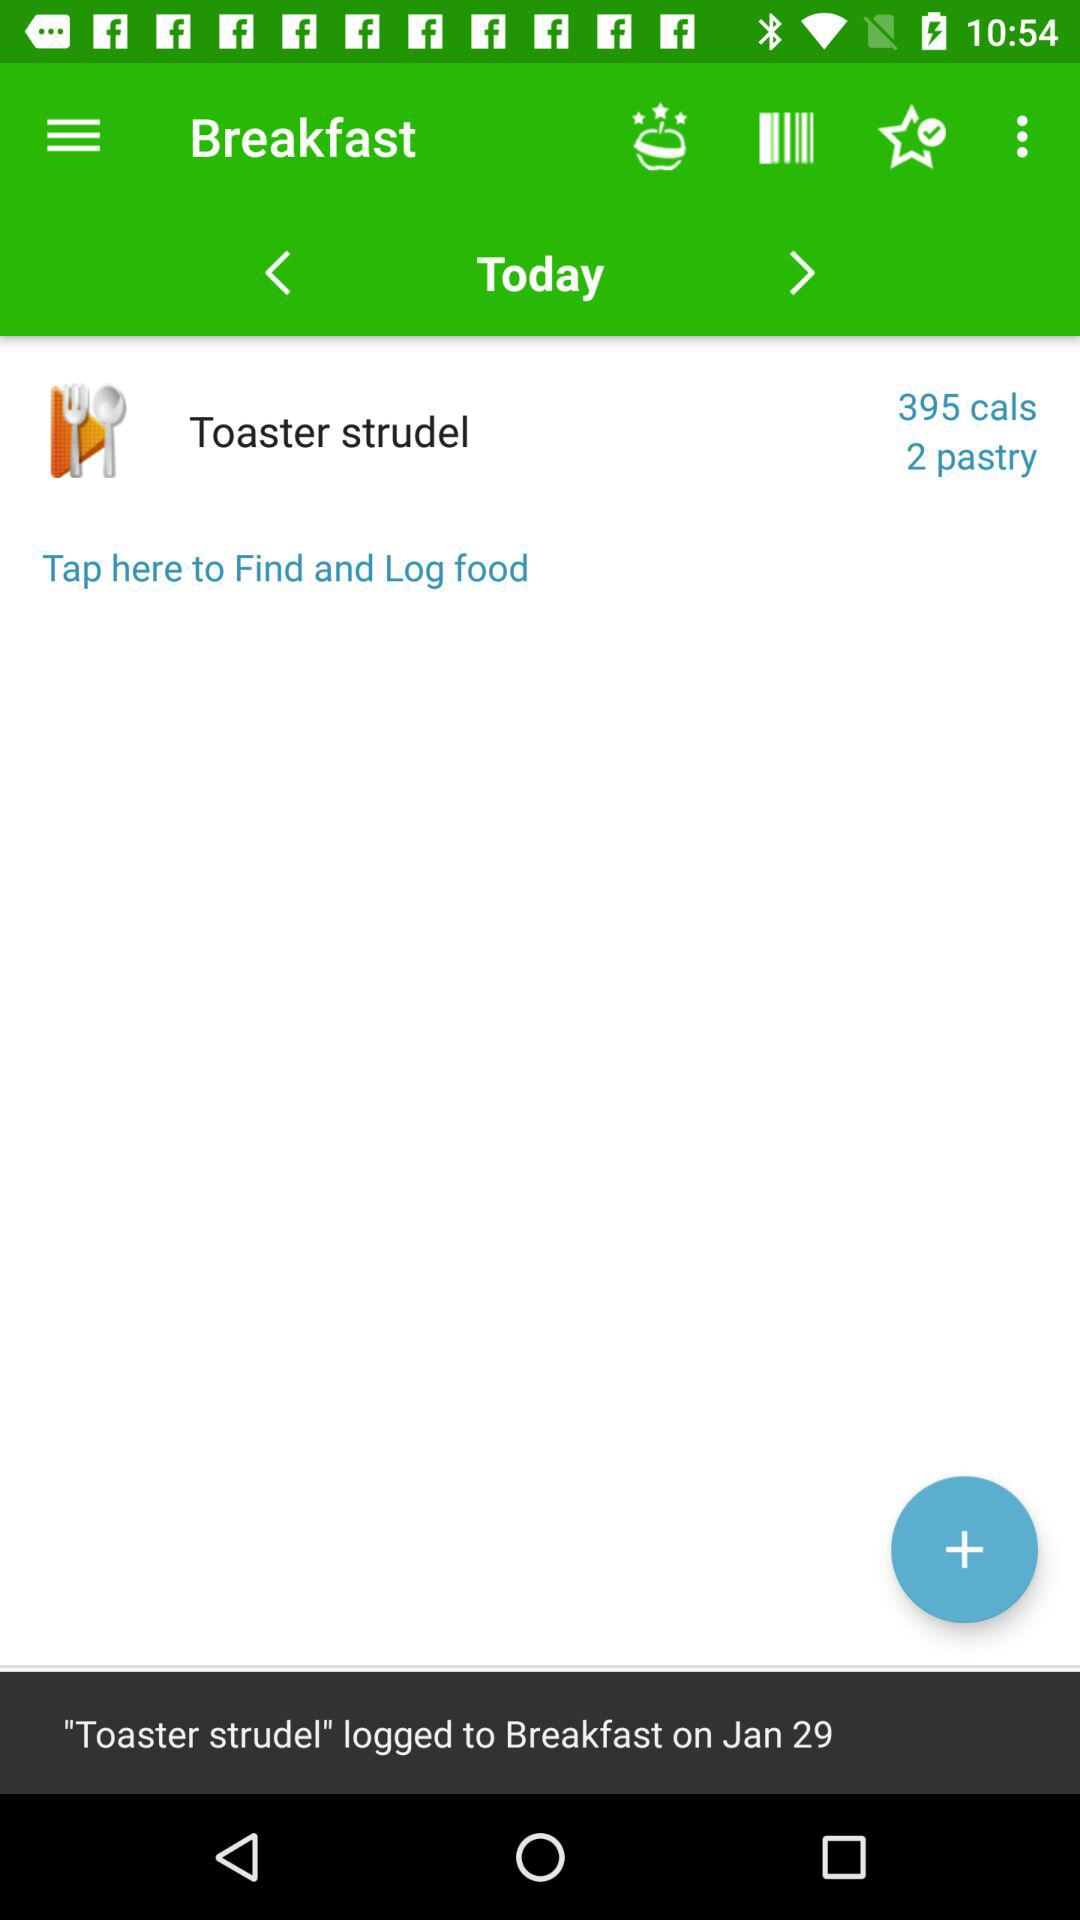What is today's breakfast? Today's breakfast is a toaster strudel. 